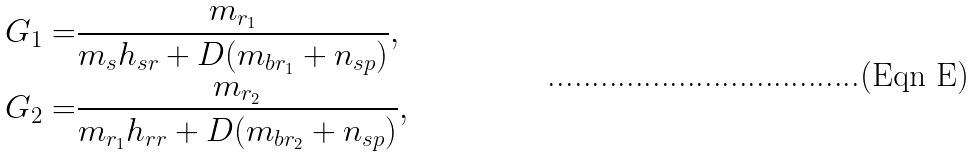<formula> <loc_0><loc_0><loc_500><loc_500>G _ { 1 } = & \frac { m _ { r _ { 1 } } } { m _ { s } h _ { s r } + D ( m _ { b r _ { 1 } } + n _ { s p } ) } , \\ G _ { 2 } = & \frac { m _ { r _ { 2 } } } { m _ { r _ { 1 } } h _ { r r } + D ( m _ { b r _ { 2 } } + n _ { s p } ) } ,</formula> 